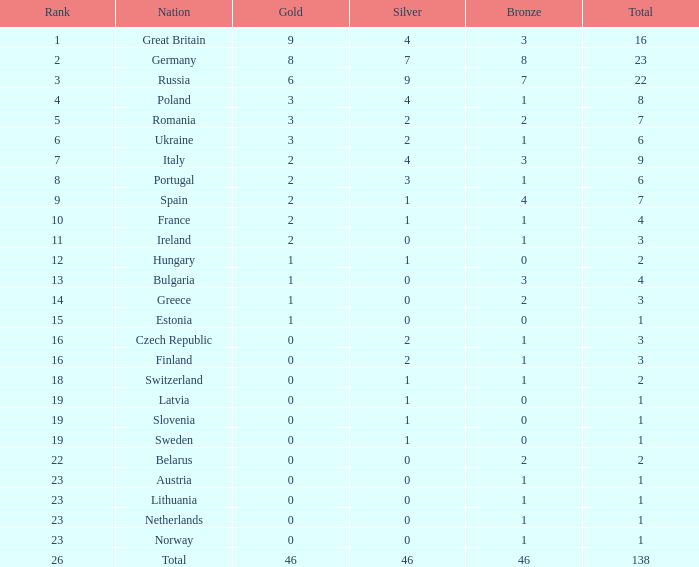What is the most bronze can be when silver is larger than 2, and the nation is germany, and gold is more than 8? None. 